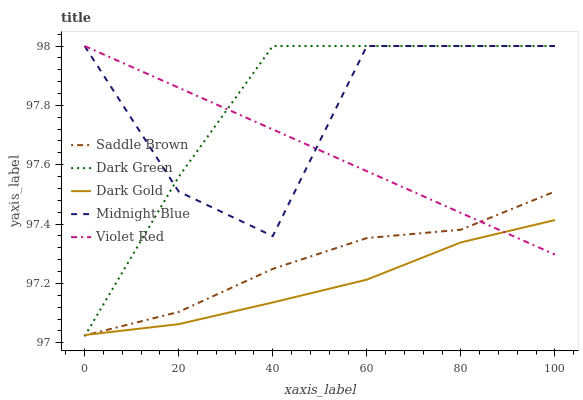Does Dark Gold have the minimum area under the curve?
Answer yes or no. Yes. Does Dark Green have the maximum area under the curve?
Answer yes or no. Yes. Does Violet Red have the minimum area under the curve?
Answer yes or no. No. Does Violet Red have the maximum area under the curve?
Answer yes or no. No. Is Violet Red the smoothest?
Answer yes or no. Yes. Is Midnight Blue the roughest?
Answer yes or no. Yes. Is Dark Gold the smoothest?
Answer yes or no. No. Is Dark Gold the roughest?
Answer yes or no. No. Does Violet Red have the lowest value?
Answer yes or no. No. Does Dark Green have the highest value?
Answer yes or no. Yes. Does Dark Gold have the highest value?
Answer yes or no. No. Is Saddle Brown less than Midnight Blue?
Answer yes or no. Yes. Is Midnight Blue greater than Dark Gold?
Answer yes or no. Yes. Does Saddle Brown intersect Dark Gold?
Answer yes or no. Yes. Is Saddle Brown less than Dark Gold?
Answer yes or no. No. Is Saddle Brown greater than Dark Gold?
Answer yes or no. No. Does Saddle Brown intersect Midnight Blue?
Answer yes or no. No. 